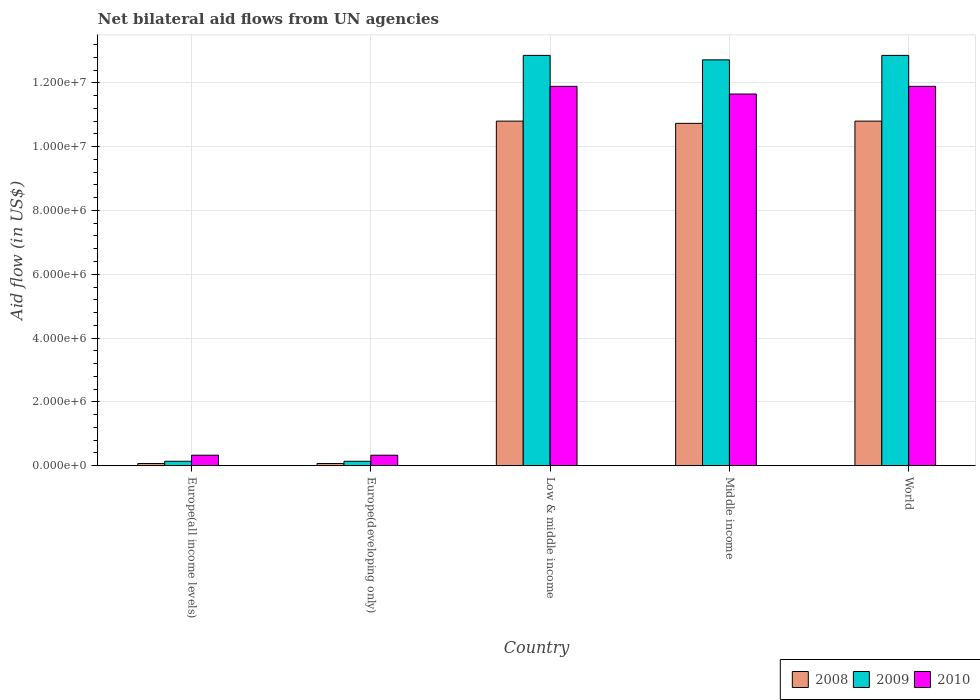How many groups of bars are there?
Your response must be concise. 5. How many bars are there on the 3rd tick from the left?
Make the answer very short. 3. What is the label of the 3rd group of bars from the left?
Provide a short and direct response. Low & middle income. In how many cases, is the number of bars for a given country not equal to the number of legend labels?
Provide a succinct answer. 0. What is the net bilateral aid flow in 2008 in Middle income?
Provide a succinct answer. 1.07e+07. Across all countries, what is the maximum net bilateral aid flow in 2009?
Offer a terse response. 1.29e+07. In which country was the net bilateral aid flow in 2009 minimum?
Keep it short and to the point. Europe(all income levels). What is the total net bilateral aid flow in 2008 in the graph?
Make the answer very short. 3.25e+07. What is the difference between the net bilateral aid flow in 2009 in Europe(all income levels) and that in World?
Offer a terse response. -1.27e+07. What is the difference between the net bilateral aid flow in 2009 in World and the net bilateral aid flow in 2008 in Middle income?
Offer a terse response. 2.13e+06. What is the average net bilateral aid flow in 2010 per country?
Give a very brief answer. 7.22e+06. What is the difference between the net bilateral aid flow of/in 2008 and net bilateral aid flow of/in 2009 in Middle income?
Provide a short and direct response. -1.99e+06. What is the ratio of the net bilateral aid flow in 2009 in Europe(all income levels) to that in Middle income?
Your response must be concise. 0.01. What is the difference between the highest and the lowest net bilateral aid flow in 2008?
Your answer should be very brief. 1.07e+07. What does the 2nd bar from the right in World represents?
Make the answer very short. 2009. Is it the case that in every country, the sum of the net bilateral aid flow in 2009 and net bilateral aid flow in 2010 is greater than the net bilateral aid flow in 2008?
Give a very brief answer. Yes. Are all the bars in the graph horizontal?
Offer a terse response. No. What is the difference between two consecutive major ticks on the Y-axis?
Ensure brevity in your answer.  2.00e+06. How are the legend labels stacked?
Provide a succinct answer. Horizontal. What is the title of the graph?
Your answer should be compact. Net bilateral aid flows from UN agencies. What is the label or title of the Y-axis?
Make the answer very short. Aid flow (in US$). What is the Aid flow (in US$) of 2008 in Europe(all income levels)?
Make the answer very short. 7.00e+04. What is the Aid flow (in US$) in 2009 in Europe(all income levels)?
Provide a short and direct response. 1.40e+05. What is the Aid flow (in US$) of 2010 in Europe(developing only)?
Ensure brevity in your answer.  3.30e+05. What is the Aid flow (in US$) in 2008 in Low & middle income?
Offer a terse response. 1.08e+07. What is the Aid flow (in US$) in 2009 in Low & middle income?
Your answer should be compact. 1.29e+07. What is the Aid flow (in US$) in 2010 in Low & middle income?
Provide a short and direct response. 1.19e+07. What is the Aid flow (in US$) of 2008 in Middle income?
Offer a very short reply. 1.07e+07. What is the Aid flow (in US$) of 2009 in Middle income?
Make the answer very short. 1.27e+07. What is the Aid flow (in US$) of 2010 in Middle income?
Your answer should be very brief. 1.16e+07. What is the Aid flow (in US$) in 2008 in World?
Give a very brief answer. 1.08e+07. What is the Aid flow (in US$) in 2009 in World?
Your answer should be very brief. 1.29e+07. What is the Aid flow (in US$) in 2010 in World?
Provide a succinct answer. 1.19e+07. Across all countries, what is the maximum Aid flow (in US$) of 2008?
Provide a short and direct response. 1.08e+07. Across all countries, what is the maximum Aid flow (in US$) of 2009?
Offer a very short reply. 1.29e+07. Across all countries, what is the maximum Aid flow (in US$) in 2010?
Provide a short and direct response. 1.19e+07. Across all countries, what is the minimum Aid flow (in US$) in 2008?
Give a very brief answer. 7.00e+04. What is the total Aid flow (in US$) in 2008 in the graph?
Provide a succinct answer. 3.25e+07. What is the total Aid flow (in US$) of 2009 in the graph?
Your answer should be very brief. 3.87e+07. What is the total Aid flow (in US$) of 2010 in the graph?
Make the answer very short. 3.61e+07. What is the difference between the Aid flow (in US$) in 2008 in Europe(all income levels) and that in Low & middle income?
Keep it short and to the point. -1.07e+07. What is the difference between the Aid flow (in US$) in 2009 in Europe(all income levels) and that in Low & middle income?
Your answer should be very brief. -1.27e+07. What is the difference between the Aid flow (in US$) in 2010 in Europe(all income levels) and that in Low & middle income?
Provide a short and direct response. -1.16e+07. What is the difference between the Aid flow (in US$) in 2008 in Europe(all income levels) and that in Middle income?
Offer a very short reply. -1.07e+07. What is the difference between the Aid flow (in US$) in 2009 in Europe(all income levels) and that in Middle income?
Ensure brevity in your answer.  -1.26e+07. What is the difference between the Aid flow (in US$) of 2010 in Europe(all income levels) and that in Middle income?
Keep it short and to the point. -1.13e+07. What is the difference between the Aid flow (in US$) of 2008 in Europe(all income levels) and that in World?
Your response must be concise. -1.07e+07. What is the difference between the Aid flow (in US$) in 2009 in Europe(all income levels) and that in World?
Your response must be concise. -1.27e+07. What is the difference between the Aid flow (in US$) in 2010 in Europe(all income levels) and that in World?
Make the answer very short. -1.16e+07. What is the difference between the Aid flow (in US$) of 2008 in Europe(developing only) and that in Low & middle income?
Your answer should be compact. -1.07e+07. What is the difference between the Aid flow (in US$) in 2009 in Europe(developing only) and that in Low & middle income?
Ensure brevity in your answer.  -1.27e+07. What is the difference between the Aid flow (in US$) in 2010 in Europe(developing only) and that in Low & middle income?
Your answer should be very brief. -1.16e+07. What is the difference between the Aid flow (in US$) of 2008 in Europe(developing only) and that in Middle income?
Offer a very short reply. -1.07e+07. What is the difference between the Aid flow (in US$) of 2009 in Europe(developing only) and that in Middle income?
Give a very brief answer. -1.26e+07. What is the difference between the Aid flow (in US$) in 2010 in Europe(developing only) and that in Middle income?
Your answer should be very brief. -1.13e+07. What is the difference between the Aid flow (in US$) of 2008 in Europe(developing only) and that in World?
Your answer should be very brief. -1.07e+07. What is the difference between the Aid flow (in US$) in 2009 in Europe(developing only) and that in World?
Your answer should be very brief. -1.27e+07. What is the difference between the Aid flow (in US$) of 2010 in Europe(developing only) and that in World?
Offer a very short reply. -1.16e+07. What is the difference between the Aid flow (in US$) of 2008 in Low & middle income and that in Middle income?
Give a very brief answer. 7.00e+04. What is the difference between the Aid flow (in US$) in 2009 in Low & middle income and that in Middle income?
Offer a very short reply. 1.40e+05. What is the difference between the Aid flow (in US$) in 2010 in Low & middle income and that in Middle income?
Your response must be concise. 2.40e+05. What is the difference between the Aid flow (in US$) in 2009 in Low & middle income and that in World?
Your answer should be compact. 0. What is the difference between the Aid flow (in US$) in 2010 in Low & middle income and that in World?
Provide a short and direct response. 0. What is the difference between the Aid flow (in US$) in 2008 in Middle income and that in World?
Keep it short and to the point. -7.00e+04. What is the difference between the Aid flow (in US$) in 2010 in Middle income and that in World?
Give a very brief answer. -2.40e+05. What is the difference between the Aid flow (in US$) of 2008 in Europe(all income levels) and the Aid flow (in US$) of 2009 in Europe(developing only)?
Your response must be concise. -7.00e+04. What is the difference between the Aid flow (in US$) of 2008 in Europe(all income levels) and the Aid flow (in US$) of 2010 in Europe(developing only)?
Provide a short and direct response. -2.60e+05. What is the difference between the Aid flow (in US$) of 2008 in Europe(all income levels) and the Aid flow (in US$) of 2009 in Low & middle income?
Your answer should be very brief. -1.28e+07. What is the difference between the Aid flow (in US$) in 2008 in Europe(all income levels) and the Aid flow (in US$) in 2010 in Low & middle income?
Your response must be concise. -1.18e+07. What is the difference between the Aid flow (in US$) in 2009 in Europe(all income levels) and the Aid flow (in US$) in 2010 in Low & middle income?
Your response must be concise. -1.18e+07. What is the difference between the Aid flow (in US$) in 2008 in Europe(all income levels) and the Aid flow (in US$) in 2009 in Middle income?
Keep it short and to the point. -1.26e+07. What is the difference between the Aid flow (in US$) in 2008 in Europe(all income levels) and the Aid flow (in US$) in 2010 in Middle income?
Offer a very short reply. -1.16e+07. What is the difference between the Aid flow (in US$) of 2009 in Europe(all income levels) and the Aid flow (in US$) of 2010 in Middle income?
Your answer should be compact. -1.15e+07. What is the difference between the Aid flow (in US$) in 2008 in Europe(all income levels) and the Aid flow (in US$) in 2009 in World?
Your answer should be compact. -1.28e+07. What is the difference between the Aid flow (in US$) of 2008 in Europe(all income levels) and the Aid flow (in US$) of 2010 in World?
Provide a short and direct response. -1.18e+07. What is the difference between the Aid flow (in US$) in 2009 in Europe(all income levels) and the Aid flow (in US$) in 2010 in World?
Provide a short and direct response. -1.18e+07. What is the difference between the Aid flow (in US$) of 2008 in Europe(developing only) and the Aid flow (in US$) of 2009 in Low & middle income?
Provide a short and direct response. -1.28e+07. What is the difference between the Aid flow (in US$) in 2008 in Europe(developing only) and the Aid flow (in US$) in 2010 in Low & middle income?
Offer a terse response. -1.18e+07. What is the difference between the Aid flow (in US$) in 2009 in Europe(developing only) and the Aid flow (in US$) in 2010 in Low & middle income?
Provide a short and direct response. -1.18e+07. What is the difference between the Aid flow (in US$) of 2008 in Europe(developing only) and the Aid flow (in US$) of 2009 in Middle income?
Offer a terse response. -1.26e+07. What is the difference between the Aid flow (in US$) in 2008 in Europe(developing only) and the Aid flow (in US$) in 2010 in Middle income?
Offer a very short reply. -1.16e+07. What is the difference between the Aid flow (in US$) in 2009 in Europe(developing only) and the Aid flow (in US$) in 2010 in Middle income?
Your response must be concise. -1.15e+07. What is the difference between the Aid flow (in US$) of 2008 in Europe(developing only) and the Aid flow (in US$) of 2009 in World?
Your answer should be very brief. -1.28e+07. What is the difference between the Aid flow (in US$) in 2008 in Europe(developing only) and the Aid flow (in US$) in 2010 in World?
Make the answer very short. -1.18e+07. What is the difference between the Aid flow (in US$) in 2009 in Europe(developing only) and the Aid flow (in US$) in 2010 in World?
Provide a short and direct response. -1.18e+07. What is the difference between the Aid flow (in US$) in 2008 in Low & middle income and the Aid flow (in US$) in 2009 in Middle income?
Your response must be concise. -1.92e+06. What is the difference between the Aid flow (in US$) in 2008 in Low & middle income and the Aid flow (in US$) in 2010 in Middle income?
Give a very brief answer. -8.50e+05. What is the difference between the Aid flow (in US$) in 2009 in Low & middle income and the Aid flow (in US$) in 2010 in Middle income?
Your answer should be very brief. 1.21e+06. What is the difference between the Aid flow (in US$) in 2008 in Low & middle income and the Aid flow (in US$) in 2009 in World?
Offer a terse response. -2.06e+06. What is the difference between the Aid flow (in US$) in 2008 in Low & middle income and the Aid flow (in US$) in 2010 in World?
Ensure brevity in your answer.  -1.09e+06. What is the difference between the Aid flow (in US$) in 2009 in Low & middle income and the Aid flow (in US$) in 2010 in World?
Your answer should be compact. 9.70e+05. What is the difference between the Aid flow (in US$) in 2008 in Middle income and the Aid flow (in US$) in 2009 in World?
Make the answer very short. -2.13e+06. What is the difference between the Aid flow (in US$) of 2008 in Middle income and the Aid flow (in US$) of 2010 in World?
Give a very brief answer. -1.16e+06. What is the difference between the Aid flow (in US$) in 2009 in Middle income and the Aid flow (in US$) in 2010 in World?
Keep it short and to the point. 8.30e+05. What is the average Aid flow (in US$) of 2008 per country?
Provide a short and direct response. 6.49e+06. What is the average Aid flow (in US$) of 2009 per country?
Your answer should be compact. 7.74e+06. What is the average Aid flow (in US$) of 2010 per country?
Provide a short and direct response. 7.22e+06. What is the difference between the Aid flow (in US$) of 2009 and Aid flow (in US$) of 2010 in Europe(all income levels)?
Offer a very short reply. -1.90e+05. What is the difference between the Aid flow (in US$) of 2009 and Aid flow (in US$) of 2010 in Europe(developing only)?
Your response must be concise. -1.90e+05. What is the difference between the Aid flow (in US$) in 2008 and Aid flow (in US$) in 2009 in Low & middle income?
Your answer should be compact. -2.06e+06. What is the difference between the Aid flow (in US$) in 2008 and Aid flow (in US$) in 2010 in Low & middle income?
Ensure brevity in your answer.  -1.09e+06. What is the difference between the Aid flow (in US$) of 2009 and Aid flow (in US$) of 2010 in Low & middle income?
Your answer should be very brief. 9.70e+05. What is the difference between the Aid flow (in US$) of 2008 and Aid flow (in US$) of 2009 in Middle income?
Provide a short and direct response. -1.99e+06. What is the difference between the Aid flow (in US$) of 2008 and Aid flow (in US$) of 2010 in Middle income?
Your answer should be compact. -9.20e+05. What is the difference between the Aid flow (in US$) of 2009 and Aid flow (in US$) of 2010 in Middle income?
Your answer should be very brief. 1.07e+06. What is the difference between the Aid flow (in US$) of 2008 and Aid flow (in US$) of 2009 in World?
Make the answer very short. -2.06e+06. What is the difference between the Aid flow (in US$) in 2008 and Aid flow (in US$) in 2010 in World?
Provide a short and direct response. -1.09e+06. What is the difference between the Aid flow (in US$) of 2009 and Aid flow (in US$) of 2010 in World?
Offer a terse response. 9.70e+05. What is the ratio of the Aid flow (in US$) in 2008 in Europe(all income levels) to that in Europe(developing only)?
Ensure brevity in your answer.  1. What is the ratio of the Aid flow (in US$) of 2009 in Europe(all income levels) to that in Europe(developing only)?
Offer a very short reply. 1. What is the ratio of the Aid flow (in US$) in 2008 in Europe(all income levels) to that in Low & middle income?
Offer a terse response. 0.01. What is the ratio of the Aid flow (in US$) in 2009 in Europe(all income levels) to that in Low & middle income?
Ensure brevity in your answer.  0.01. What is the ratio of the Aid flow (in US$) of 2010 in Europe(all income levels) to that in Low & middle income?
Provide a short and direct response. 0.03. What is the ratio of the Aid flow (in US$) of 2008 in Europe(all income levels) to that in Middle income?
Provide a short and direct response. 0.01. What is the ratio of the Aid flow (in US$) of 2009 in Europe(all income levels) to that in Middle income?
Make the answer very short. 0.01. What is the ratio of the Aid flow (in US$) in 2010 in Europe(all income levels) to that in Middle income?
Offer a very short reply. 0.03. What is the ratio of the Aid flow (in US$) in 2008 in Europe(all income levels) to that in World?
Offer a terse response. 0.01. What is the ratio of the Aid flow (in US$) of 2009 in Europe(all income levels) to that in World?
Make the answer very short. 0.01. What is the ratio of the Aid flow (in US$) in 2010 in Europe(all income levels) to that in World?
Offer a very short reply. 0.03. What is the ratio of the Aid flow (in US$) of 2008 in Europe(developing only) to that in Low & middle income?
Give a very brief answer. 0.01. What is the ratio of the Aid flow (in US$) of 2009 in Europe(developing only) to that in Low & middle income?
Provide a succinct answer. 0.01. What is the ratio of the Aid flow (in US$) of 2010 in Europe(developing only) to that in Low & middle income?
Give a very brief answer. 0.03. What is the ratio of the Aid flow (in US$) in 2008 in Europe(developing only) to that in Middle income?
Provide a succinct answer. 0.01. What is the ratio of the Aid flow (in US$) of 2009 in Europe(developing only) to that in Middle income?
Give a very brief answer. 0.01. What is the ratio of the Aid flow (in US$) of 2010 in Europe(developing only) to that in Middle income?
Provide a short and direct response. 0.03. What is the ratio of the Aid flow (in US$) of 2008 in Europe(developing only) to that in World?
Provide a succinct answer. 0.01. What is the ratio of the Aid flow (in US$) of 2009 in Europe(developing only) to that in World?
Offer a terse response. 0.01. What is the ratio of the Aid flow (in US$) in 2010 in Europe(developing only) to that in World?
Offer a very short reply. 0.03. What is the ratio of the Aid flow (in US$) of 2008 in Low & middle income to that in Middle income?
Offer a terse response. 1.01. What is the ratio of the Aid flow (in US$) of 2009 in Low & middle income to that in Middle income?
Offer a terse response. 1.01. What is the ratio of the Aid flow (in US$) in 2010 in Low & middle income to that in Middle income?
Ensure brevity in your answer.  1.02. What is the ratio of the Aid flow (in US$) of 2008 in Low & middle income to that in World?
Provide a succinct answer. 1. What is the ratio of the Aid flow (in US$) in 2009 in Low & middle income to that in World?
Your response must be concise. 1. What is the ratio of the Aid flow (in US$) of 2008 in Middle income to that in World?
Your answer should be compact. 0.99. What is the ratio of the Aid flow (in US$) in 2010 in Middle income to that in World?
Your answer should be compact. 0.98. What is the difference between the highest and the second highest Aid flow (in US$) of 2009?
Your answer should be compact. 0. What is the difference between the highest and the lowest Aid flow (in US$) of 2008?
Make the answer very short. 1.07e+07. What is the difference between the highest and the lowest Aid flow (in US$) of 2009?
Offer a very short reply. 1.27e+07. What is the difference between the highest and the lowest Aid flow (in US$) of 2010?
Offer a terse response. 1.16e+07. 